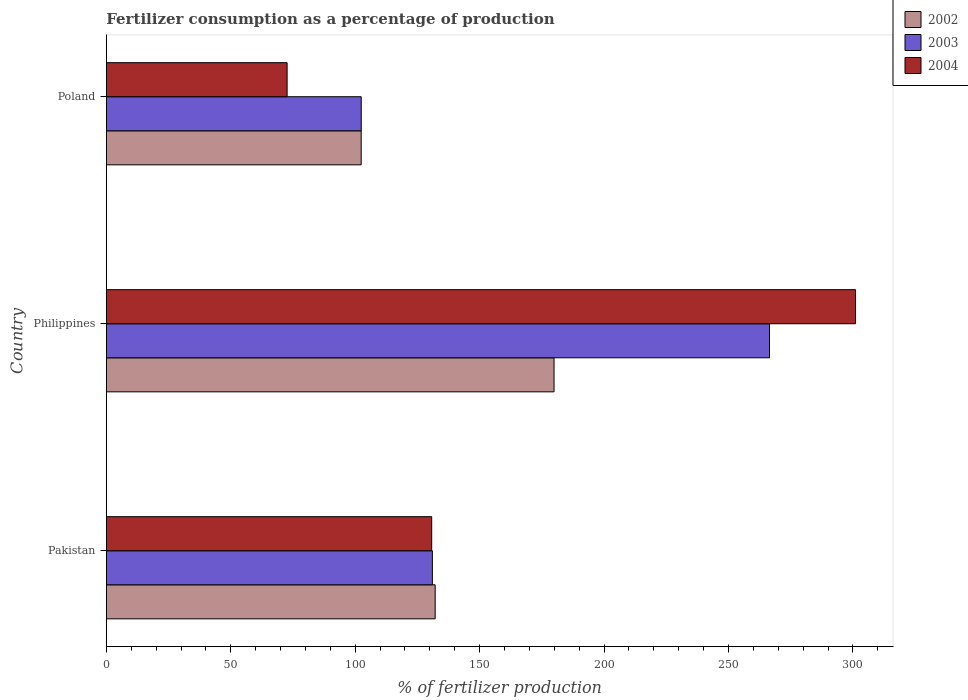How many different coloured bars are there?
Provide a succinct answer. 3. How many groups of bars are there?
Your answer should be compact. 3. Are the number of bars per tick equal to the number of legend labels?
Offer a very short reply. Yes. Are the number of bars on each tick of the Y-axis equal?
Keep it short and to the point. Yes. How many bars are there on the 2nd tick from the top?
Provide a short and direct response. 3. How many bars are there on the 3rd tick from the bottom?
Offer a very short reply. 3. What is the percentage of fertilizers consumed in 2002 in Pakistan?
Ensure brevity in your answer.  132.13. Across all countries, what is the maximum percentage of fertilizers consumed in 2002?
Provide a short and direct response. 179.9. Across all countries, what is the minimum percentage of fertilizers consumed in 2002?
Ensure brevity in your answer.  102.4. In which country was the percentage of fertilizers consumed in 2002 minimum?
Your response must be concise. Poland. What is the total percentage of fertilizers consumed in 2002 in the graph?
Provide a short and direct response. 414.44. What is the difference between the percentage of fertilizers consumed in 2002 in Pakistan and that in Poland?
Make the answer very short. 29.73. What is the difference between the percentage of fertilizers consumed in 2003 in Poland and the percentage of fertilizers consumed in 2004 in Pakistan?
Your answer should be compact. -28.31. What is the average percentage of fertilizers consumed in 2002 per country?
Provide a short and direct response. 138.15. What is the difference between the percentage of fertilizers consumed in 2004 and percentage of fertilizers consumed in 2003 in Philippines?
Make the answer very short. 34.56. In how many countries, is the percentage of fertilizers consumed in 2003 greater than 100 %?
Give a very brief answer. 3. What is the ratio of the percentage of fertilizers consumed in 2003 in Pakistan to that in Poland?
Make the answer very short. 1.28. What is the difference between the highest and the second highest percentage of fertilizers consumed in 2004?
Make the answer very short. 170.31. What is the difference between the highest and the lowest percentage of fertilizers consumed in 2004?
Keep it short and to the point. 228.4. In how many countries, is the percentage of fertilizers consumed in 2004 greater than the average percentage of fertilizers consumed in 2004 taken over all countries?
Provide a short and direct response. 1. How many bars are there?
Offer a very short reply. 9. How many countries are there in the graph?
Provide a succinct answer. 3. What is the difference between two consecutive major ticks on the X-axis?
Ensure brevity in your answer.  50. Does the graph contain any zero values?
Provide a short and direct response. No. Does the graph contain grids?
Provide a succinct answer. No. How many legend labels are there?
Your answer should be compact. 3. What is the title of the graph?
Ensure brevity in your answer.  Fertilizer consumption as a percentage of production. Does "1986" appear as one of the legend labels in the graph?
Provide a short and direct response. No. What is the label or title of the X-axis?
Your answer should be compact. % of fertilizer production. What is the % of fertilizer production in 2002 in Pakistan?
Give a very brief answer. 132.13. What is the % of fertilizer production in 2003 in Pakistan?
Offer a very short reply. 131.01. What is the % of fertilizer production of 2004 in Pakistan?
Provide a succinct answer. 130.73. What is the % of fertilizer production of 2002 in Philippines?
Your answer should be compact. 179.9. What is the % of fertilizer production of 2003 in Philippines?
Ensure brevity in your answer.  266.48. What is the % of fertilizer production of 2004 in Philippines?
Provide a succinct answer. 301.04. What is the % of fertilizer production in 2002 in Poland?
Offer a very short reply. 102.4. What is the % of fertilizer production of 2003 in Poland?
Your response must be concise. 102.42. What is the % of fertilizer production in 2004 in Poland?
Keep it short and to the point. 72.64. Across all countries, what is the maximum % of fertilizer production in 2002?
Provide a short and direct response. 179.9. Across all countries, what is the maximum % of fertilizer production of 2003?
Your answer should be very brief. 266.48. Across all countries, what is the maximum % of fertilizer production in 2004?
Provide a short and direct response. 301.04. Across all countries, what is the minimum % of fertilizer production in 2002?
Offer a very short reply. 102.4. Across all countries, what is the minimum % of fertilizer production of 2003?
Ensure brevity in your answer.  102.42. Across all countries, what is the minimum % of fertilizer production in 2004?
Offer a terse response. 72.64. What is the total % of fertilizer production of 2002 in the graph?
Offer a very short reply. 414.44. What is the total % of fertilizer production in 2003 in the graph?
Offer a terse response. 499.91. What is the total % of fertilizer production in 2004 in the graph?
Your answer should be compact. 504.41. What is the difference between the % of fertilizer production in 2002 in Pakistan and that in Philippines?
Your answer should be very brief. -47.77. What is the difference between the % of fertilizer production of 2003 in Pakistan and that in Philippines?
Your response must be concise. -135.47. What is the difference between the % of fertilizer production of 2004 in Pakistan and that in Philippines?
Give a very brief answer. -170.31. What is the difference between the % of fertilizer production in 2002 in Pakistan and that in Poland?
Keep it short and to the point. 29.73. What is the difference between the % of fertilizer production in 2003 in Pakistan and that in Poland?
Provide a short and direct response. 28.59. What is the difference between the % of fertilizer production of 2004 in Pakistan and that in Poland?
Make the answer very short. 58.1. What is the difference between the % of fertilizer production of 2002 in Philippines and that in Poland?
Ensure brevity in your answer.  77.5. What is the difference between the % of fertilizer production of 2003 in Philippines and that in Poland?
Keep it short and to the point. 164.06. What is the difference between the % of fertilizer production of 2004 in Philippines and that in Poland?
Give a very brief answer. 228.4. What is the difference between the % of fertilizer production in 2002 in Pakistan and the % of fertilizer production in 2003 in Philippines?
Your answer should be very brief. -134.34. What is the difference between the % of fertilizer production of 2002 in Pakistan and the % of fertilizer production of 2004 in Philippines?
Your answer should be very brief. -168.91. What is the difference between the % of fertilizer production in 2003 in Pakistan and the % of fertilizer production in 2004 in Philippines?
Your response must be concise. -170.03. What is the difference between the % of fertilizer production in 2002 in Pakistan and the % of fertilizer production in 2003 in Poland?
Keep it short and to the point. 29.71. What is the difference between the % of fertilizer production of 2002 in Pakistan and the % of fertilizer production of 2004 in Poland?
Provide a succinct answer. 59.5. What is the difference between the % of fertilizer production in 2003 in Pakistan and the % of fertilizer production in 2004 in Poland?
Offer a terse response. 58.37. What is the difference between the % of fertilizer production of 2002 in Philippines and the % of fertilizer production of 2003 in Poland?
Provide a short and direct response. 77.48. What is the difference between the % of fertilizer production in 2002 in Philippines and the % of fertilizer production in 2004 in Poland?
Ensure brevity in your answer.  107.26. What is the difference between the % of fertilizer production in 2003 in Philippines and the % of fertilizer production in 2004 in Poland?
Provide a short and direct response. 193.84. What is the average % of fertilizer production of 2002 per country?
Offer a terse response. 138.15. What is the average % of fertilizer production of 2003 per country?
Provide a succinct answer. 166.64. What is the average % of fertilizer production of 2004 per country?
Offer a very short reply. 168.14. What is the difference between the % of fertilizer production in 2002 and % of fertilizer production in 2003 in Pakistan?
Your answer should be compact. 1.12. What is the difference between the % of fertilizer production in 2002 and % of fertilizer production in 2004 in Pakistan?
Provide a short and direct response. 1.4. What is the difference between the % of fertilizer production in 2003 and % of fertilizer production in 2004 in Pakistan?
Give a very brief answer. 0.28. What is the difference between the % of fertilizer production in 2002 and % of fertilizer production in 2003 in Philippines?
Make the answer very short. -86.58. What is the difference between the % of fertilizer production of 2002 and % of fertilizer production of 2004 in Philippines?
Your answer should be compact. -121.14. What is the difference between the % of fertilizer production in 2003 and % of fertilizer production in 2004 in Philippines?
Your answer should be compact. -34.56. What is the difference between the % of fertilizer production of 2002 and % of fertilizer production of 2003 in Poland?
Keep it short and to the point. -0.02. What is the difference between the % of fertilizer production in 2002 and % of fertilizer production in 2004 in Poland?
Your response must be concise. 29.77. What is the difference between the % of fertilizer production in 2003 and % of fertilizer production in 2004 in Poland?
Your answer should be very brief. 29.78. What is the ratio of the % of fertilizer production in 2002 in Pakistan to that in Philippines?
Ensure brevity in your answer.  0.73. What is the ratio of the % of fertilizer production of 2003 in Pakistan to that in Philippines?
Offer a terse response. 0.49. What is the ratio of the % of fertilizer production in 2004 in Pakistan to that in Philippines?
Offer a terse response. 0.43. What is the ratio of the % of fertilizer production of 2002 in Pakistan to that in Poland?
Your response must be concise. 1.29. What is the ratio of the % of fertilizer production of 2003 in Pakistan to that in Poland?
Your answer should be compact. 1.28. What is the ratio of the % of fertilizer production in 2004 in Pakistan to that in Poland?
Keep it short and to the point. 1.8. What is the ratio of the % of fertilizer production of 2002 in Philippines to that in Poland?
Give a very brief answer. 1.76. What is the ratio of the % of fertilizer production in 2003 in Philippines to that in Poland?
Keep it short and to the point. 2.6. What is the ratio of the % of fertilizer production of 2004 in Philippines to that in Poland?
Keep it short and to the point. 4.14. What is the difference between the highest and the second highest % of fertilizer production of 2002?
Your answer should be compact. 47.77. What is the difference between the highest and the second highest % of fertilizer production of 2003?
Provide a succinct answer. 135.47. What is the difference between the highest and the second highest % of fertilizer production in 2004?
Offer a terse response. 170.31. What is the difference between the highest and the lowest % of fertilizer production in 2002?
Provide a short and direct response. 77.5. What is the difference between the highest and the lowest % of fertilizer production of 2003?
Your answer should be compact. 164.06. What is the difference between the highest and the lowest % of fertilizer production of 2004?
Give a very brief answer. 228.4. 